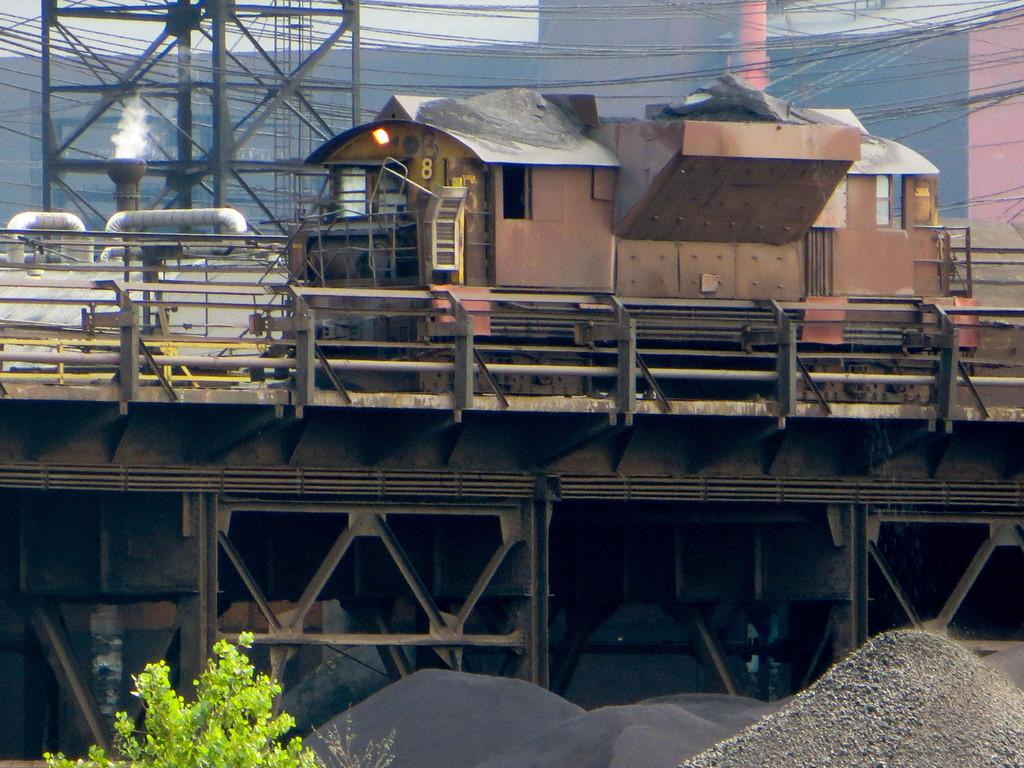What is the main subject of the image? The main subject of the image is a train. What structures are present in the image? There is a bridge, towers, a pole, and a building in the image. What other elements can be seen in the image? There are wires, stones, and a plant in the image. What is visible in the background of the image? The sky is visible in the image. How many frogs are sitting on the bed in the image? There is no bed or frogs present in the image. What type of bee can be seen buzzing around the plant in the image? There are no bees visible in the image; only a plant is present. 